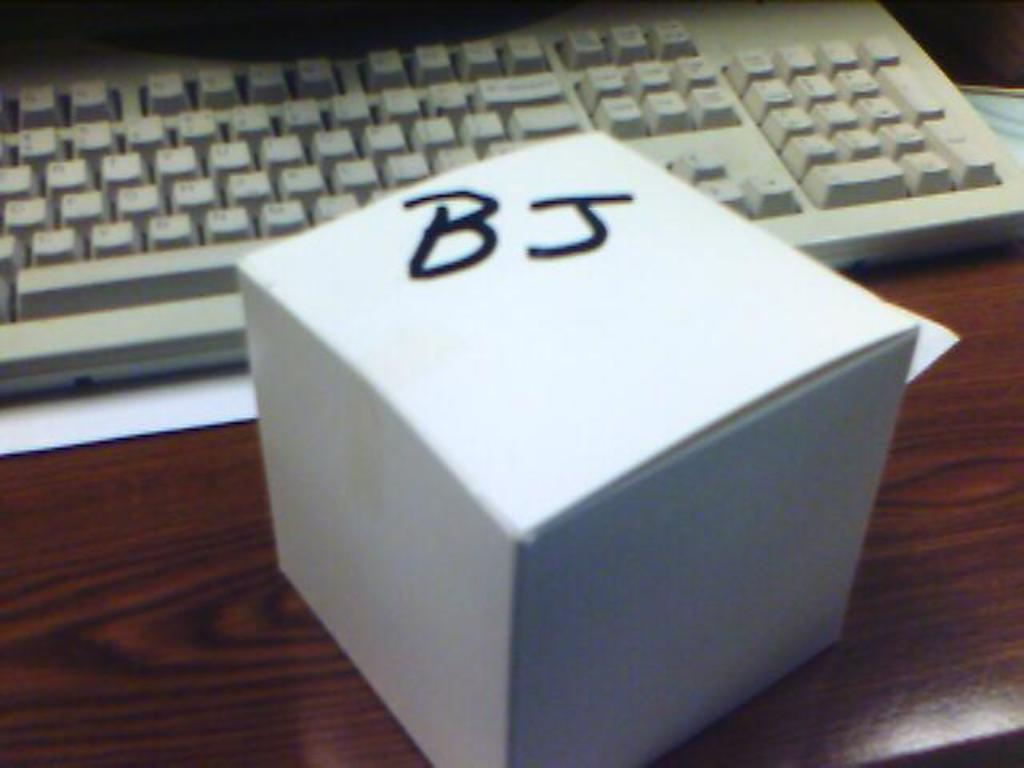What initials are on the box?
Provide a short and direct response. Bj. 